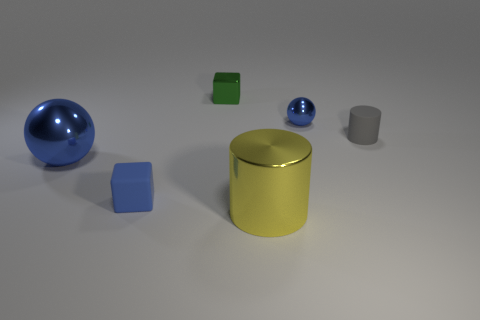Are there any large things made of the same material as the large blue sphere? In the image, there are several objects that appear to be made from similar reflective materials, like the yellow cylinder and the small blue sphere, which share a glossy texture comparable to the large blue sphere, suggesting they could be made of the same or similar material. 